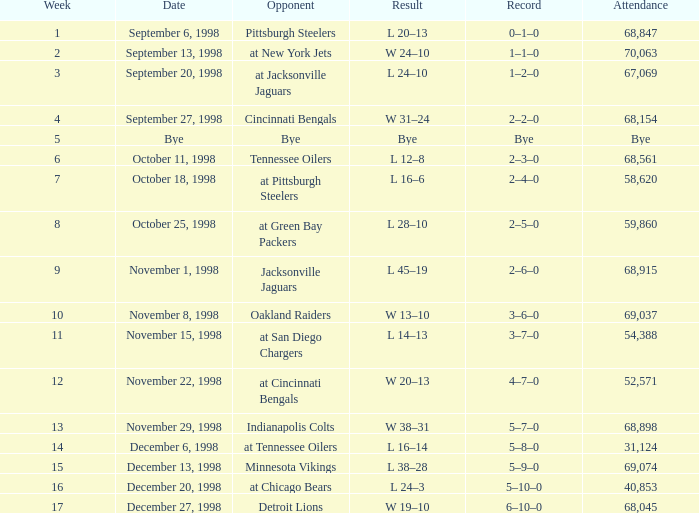Can you parse all the data within this table? {'header': ['Week', 'Date', 'Opponent', 'Result', 'Record', 'Attendance'], 'rows': [['1', 'September 6, 1998', 'Pittsburgh Steelers', 'L 20–13', '0–1–0', '68,847'], ['2', 'September 13, 1998', 'at New York Jets', 'W 24–10', '1–1–0', '70,063'], ['3', 'September 20, 1998', 'at Jacksonville Jaguars', 'L 24–10', '1–2–0', '67,069'], ['4', 'September 27, 1998', 'Cincinnati Bengals', 'W 31–24', '2–2–0', '68,154'], ['5', 'Bye', 'Bye', 'Bye', 'Bye', 'Bye'], ['6', 'October 11, 1998', 'Tennessee Oilers', 'L 12–8', '2–3–0', '68,561'], ['7', 'October 18, 1998', 'at Pittsburgh Steelers', 'L 16–6', '2–4–0', '58,620'], ['8', 'October 25, 1998', 'at Green Bay Packers', 'L 28–10', '2–5–0', '59,860'], ['9', 'November 1, 1998', 'Jacksonville Jaguars', 'L 45–19', '2–6–0', '68,915'], ['10', 'November 8, 1998', 'Oakland Raiders', 'W 13–10', '3–6–0', '69,037'], ['11', 'November 15, 1998', 'at San Diego Chargers', 'L 14–13', '3–7–0', '54,388'], ['12', 'November 22, 1998', 'at Cincinnati Bengals', 'W 20–13', '4–7–0', '52,571'], ['13', 'November 29, 1998', 'Indianapolis Colts', 'W 38–31', '5–7–0', '68,898'], ['14', 'December 6, 1998', 'at Tennessee Oilers', 'L 16–14', '5–8–0', '31,124'], ['15', 'December 13, 1998', 'Minnesota Vikings', 'L 38–28', '5–9–0', '69,074'], ['16', 'December 20, 1998', 'at Chicago Bears', 'L 24–3', '5–10–0', '40,853'], ['17', 'December 27, 1998', 'Detroit Lions', 'W 19–10', '6–10–0', '68,045']]} What is the highest week that was played against the Minnesota Vikings? 15.0. 